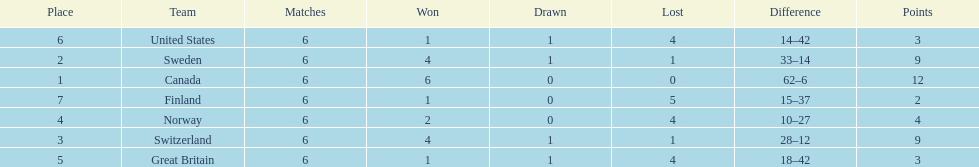How many teams won only 1 match? 3. 